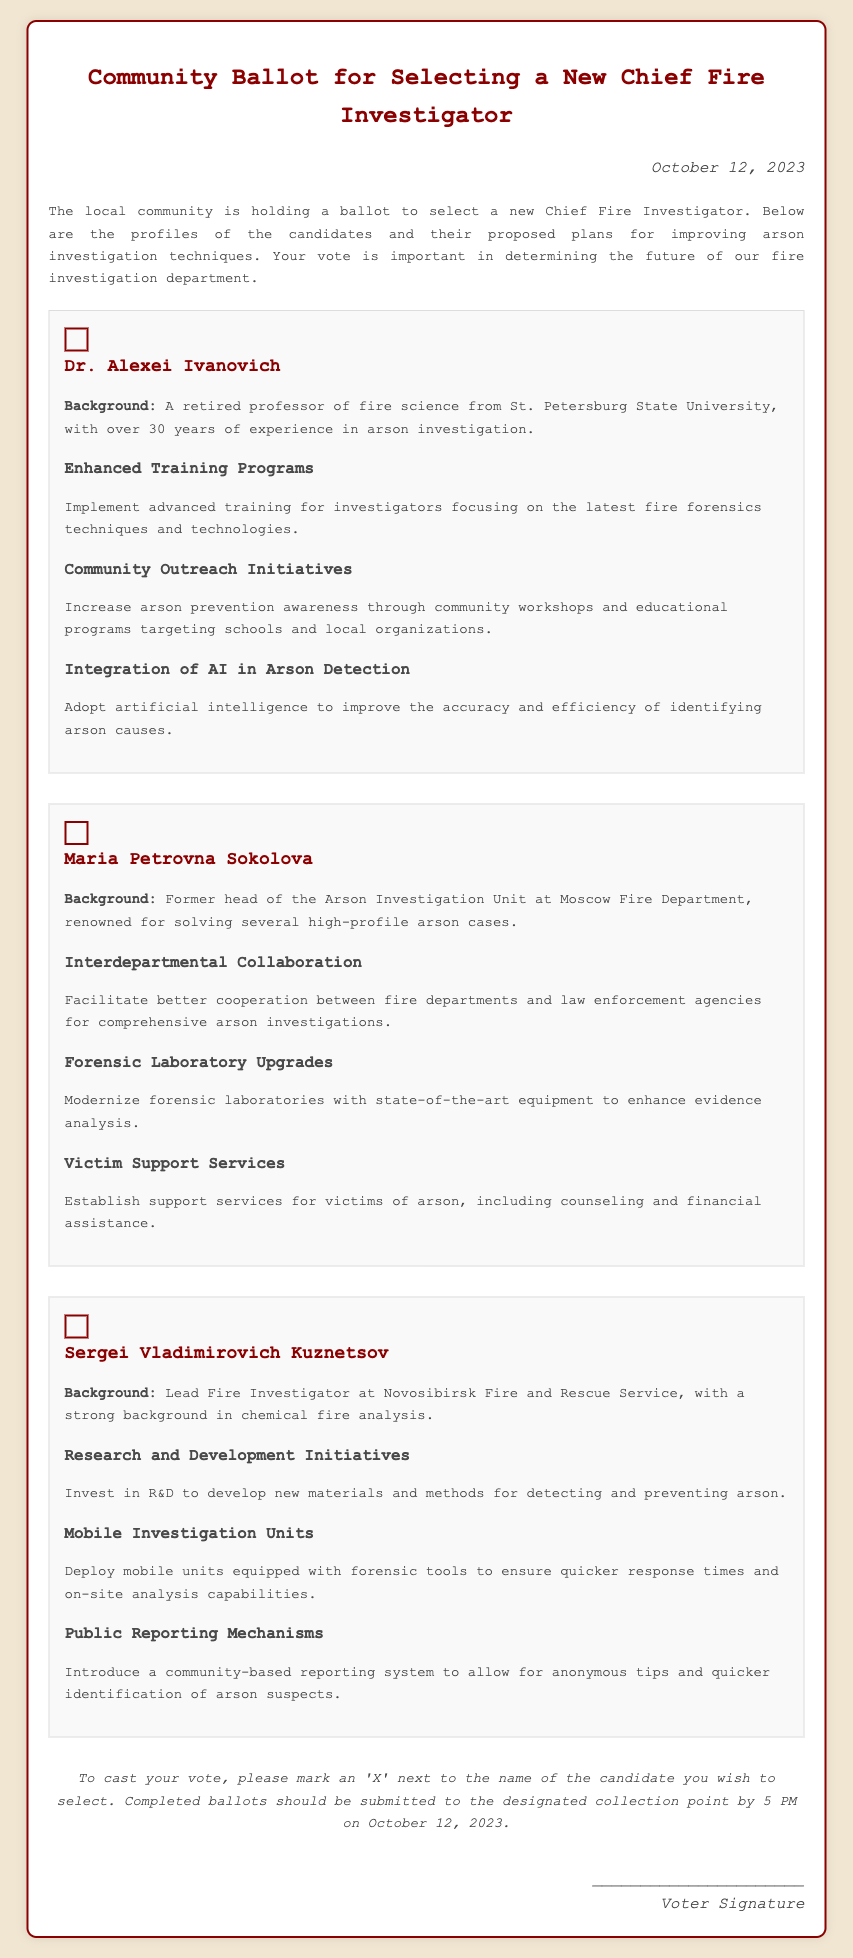What is the date of the ballot? The date of the ballot is explicitly mentioned in the document as October 12, 2023.
Answer: October 12, 2023 Who is the first candidate listed? The first candidate listed in the document is Dr. Alexei Ivanovich.
Answer: Dr. Alexei Ivanovich What is one proposed plan by Maria Petrovna Sokolova? The document lists several proposed plans by each candidate, and one of the plans by Maria Petrovna Sokolova is to modernize forensic laboratories.
Answer: Modernize forensic laboratories How many years of experience does Dr. Alexei Ivanovich have? The document states that Dr. Alexei Ivanovich has over 30 years of experience in arson investigation.
Answer: 30 years What is a key focus of Sergei Vladimirovich Kuznetsov's plans? A key focus of Sergei Vladimirovich Kuznetsov's plans is mobile investigation units.
Answer: Mobile investigation units What department did Maria Petrovna Sokolova previously lead? The document indicates that she was the former head of the Arson Investigation Unit at Moscow Fire Department.
Answer: Arson Investigation Unit What is referenced as an innovative tool for arson detection in Dr. Alexei Ivanovich's plans? In his plans, Dr. Alexei Ivanovich proposes the integration of AI in arson detection.
Answer: Integration of AI What is the voting instruction given in the document? The document instructs voters to mark an 'X' next to the name of the candidate they wish to select.
Answer: Mark an 'X' next to the name 